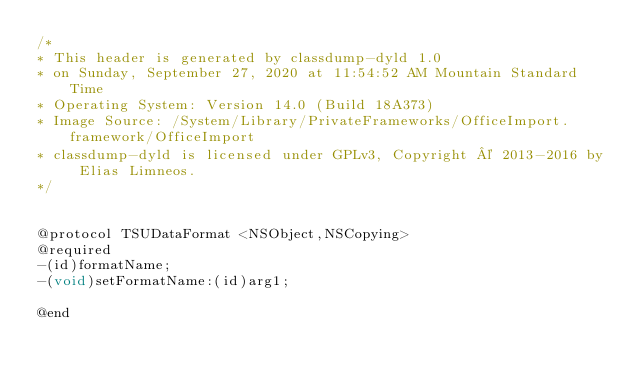Convert code to text. <code><loc_0><loc_0><loc_500><loc_500><_C_>/*
* This header is generated by classdump-dyld 1.0
* on Sunday, September 27, 2020 at 11:54:52 AM Mountain Standard Time
* Operating System: Version 14.0 (Build 18A373)
* Image Source: /System/Library/PrivateFrameworks/OfficeImport.framework/OfficeImport
* classdump-dyld is licensed under GPLv3, Copyright © 2013-2016 by Elias Limneos.
*/


@protocol TSUDataFormat <NSObject,NSCopying>
@required
-(id)formatName;
-(void)setFormatName:(id)arg1;

@end

</code> 